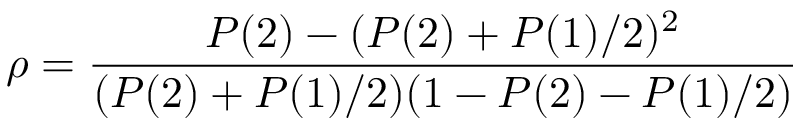<formula> <loc_0><loc_0><loc_500><loc_500>\rho = \frac { P ( 2 ) - ( P ( 2 ) + P ( 1 ) / 2 ) ^ { 2 } } { ( P ( 2 ) + P ( 1 ) / 2 ) ( 1 - P ( 2 ) - P ( 1 ) / 2 ) }</formula> 